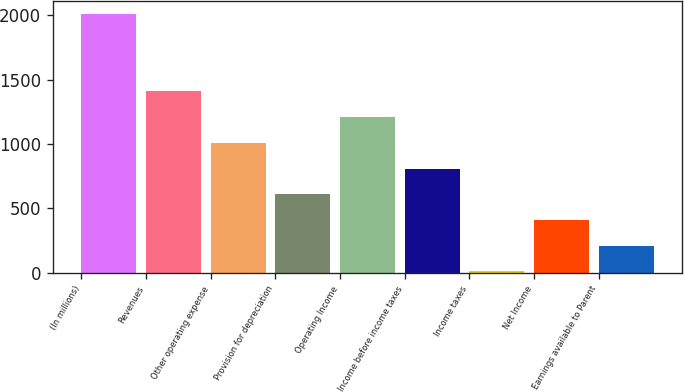Convert chart. <chart><loc_0><loc_0><loc_500><loc_500><bar_chart><fcel>(In millions)<fcel>Revenues<fcel>Other operating expense<fcel>Provision for depreciation<fcel>Operating Income<fcel>Income before income taxes<fcel>Income taxes<fcel>Net Income<fcel>Earnings available to Parent<nl><fcel>2010<fcel>1410.24<fcel>1010.4<fcel>610.56<fcel>1210.32<fcel>810.48<fcel>10.8<fcel>410.64<fcel>210.72<nl></chart> 